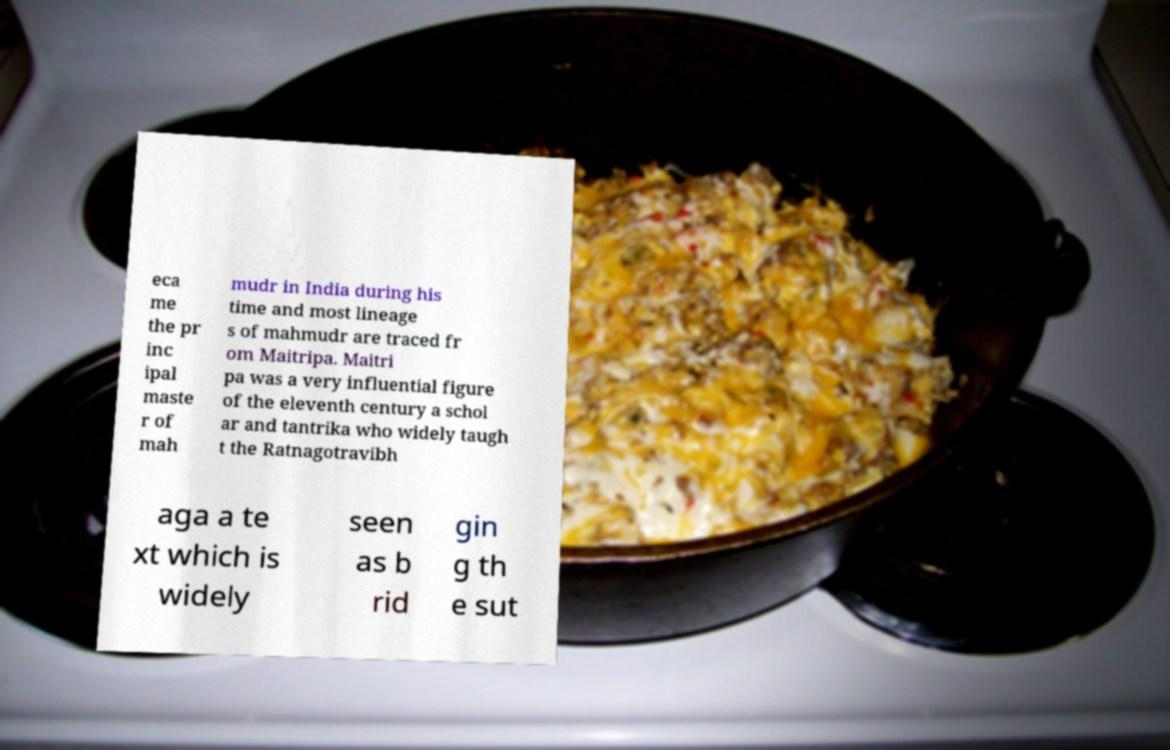Can you accurately transcribe the text from the provided image for me? eca me the pr inc ipal maste r of mah mudr in India during his time and most lineage s of mahmudr are traced fr om Maitripa. Maitri pa was a very influential figure of the eleventh century a schol ar and tantrika who widely taugh t the Ratnagotravibh aga a te xt which is widely seen as b rid gin g th e sut 